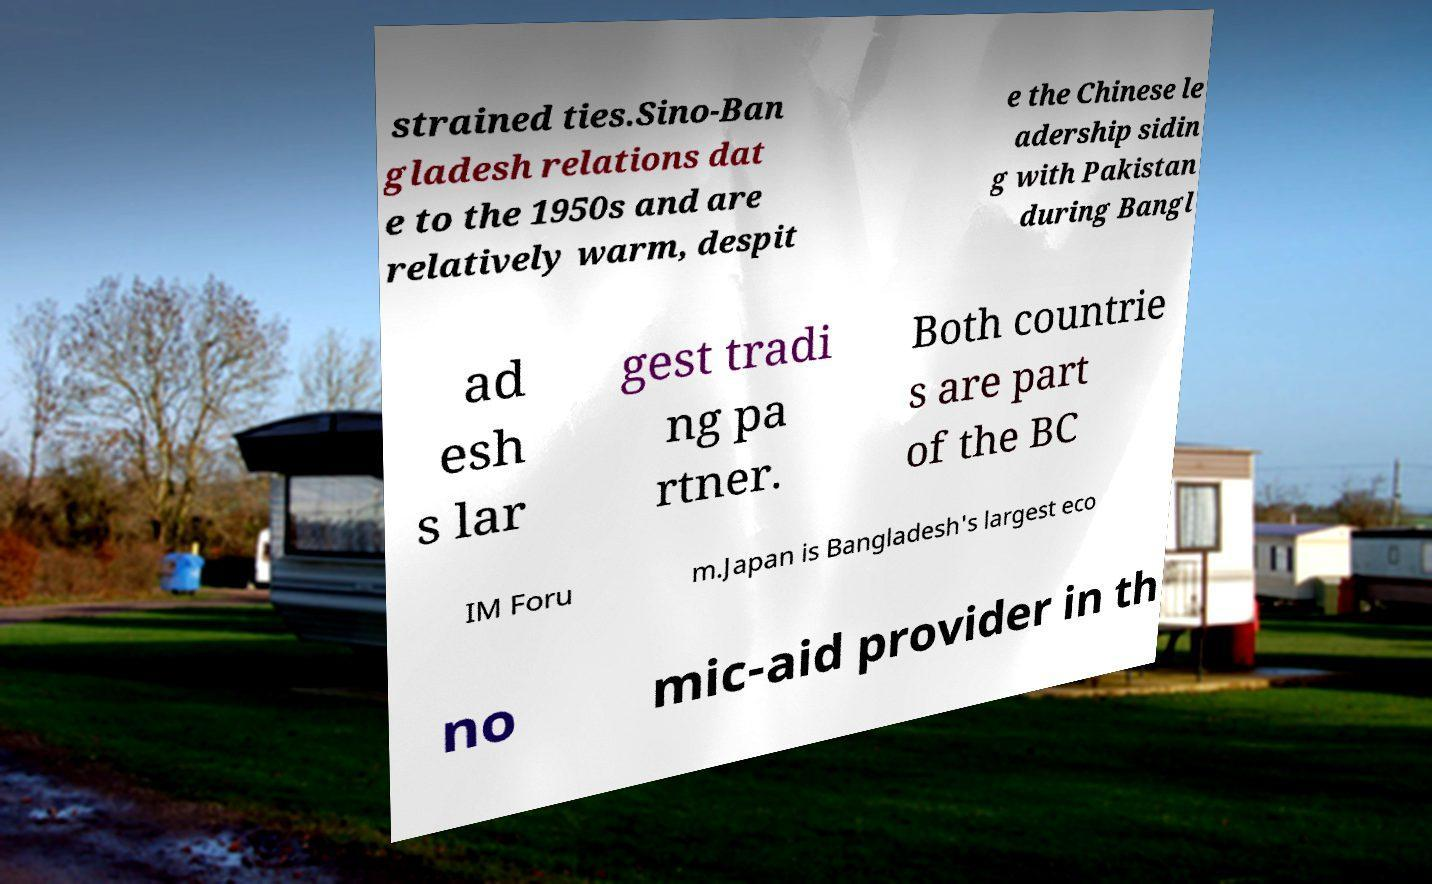Could you extract and type out the text from this image? strained ties.Sino-Ban gladesh relations dat e to the 1950s and are relatively warm, despit e the Chinese le adership sidin g with Pakistan during Bangl ad esh s lar gest tradi ng pa rtner. Both countrie s are part of the BC IM Foru m.Japan is Bangladesh's largest eco no mic-aid provider in th 